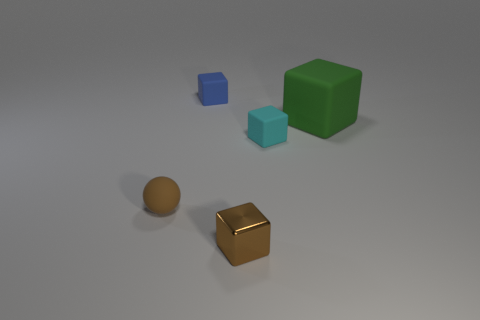Are there any other things that are made of the same material as the small brown cube?
Offer a terse response. No. Is there anything else that is the same size as the green matte block?
Give a very brief answer. No. Is there any other thing that is the same shape as the tiny brown rubber thing?
Provide a short and direct response. No. How many tiny blocks are on the left side of the small block behind the green matte object?
Keep it short and to the point. 0. How many balls are blue things or green matte objects?
Give a very brief answer. 0. There is a rubber object that is left of the small cyan cube and behind the brown rubber ball; what is its color?
Offer a terse response. Blue. Is there anything else of the same color as the small shiny block?
Make the answer very short. Yes. The matte block that is to the left of the tiny brown thing that is in front of the tiny rubber ball is what color?
Ensure brevity in your answer.  Blue. Do the green thing and the brown rubber ball have the same size?
Your answer should be very brief. No. Is the material of the tiny thing that is on the left side of the blue block the same as the tiny brown object that is right of the blue object?
Offer a very short reply. No. 